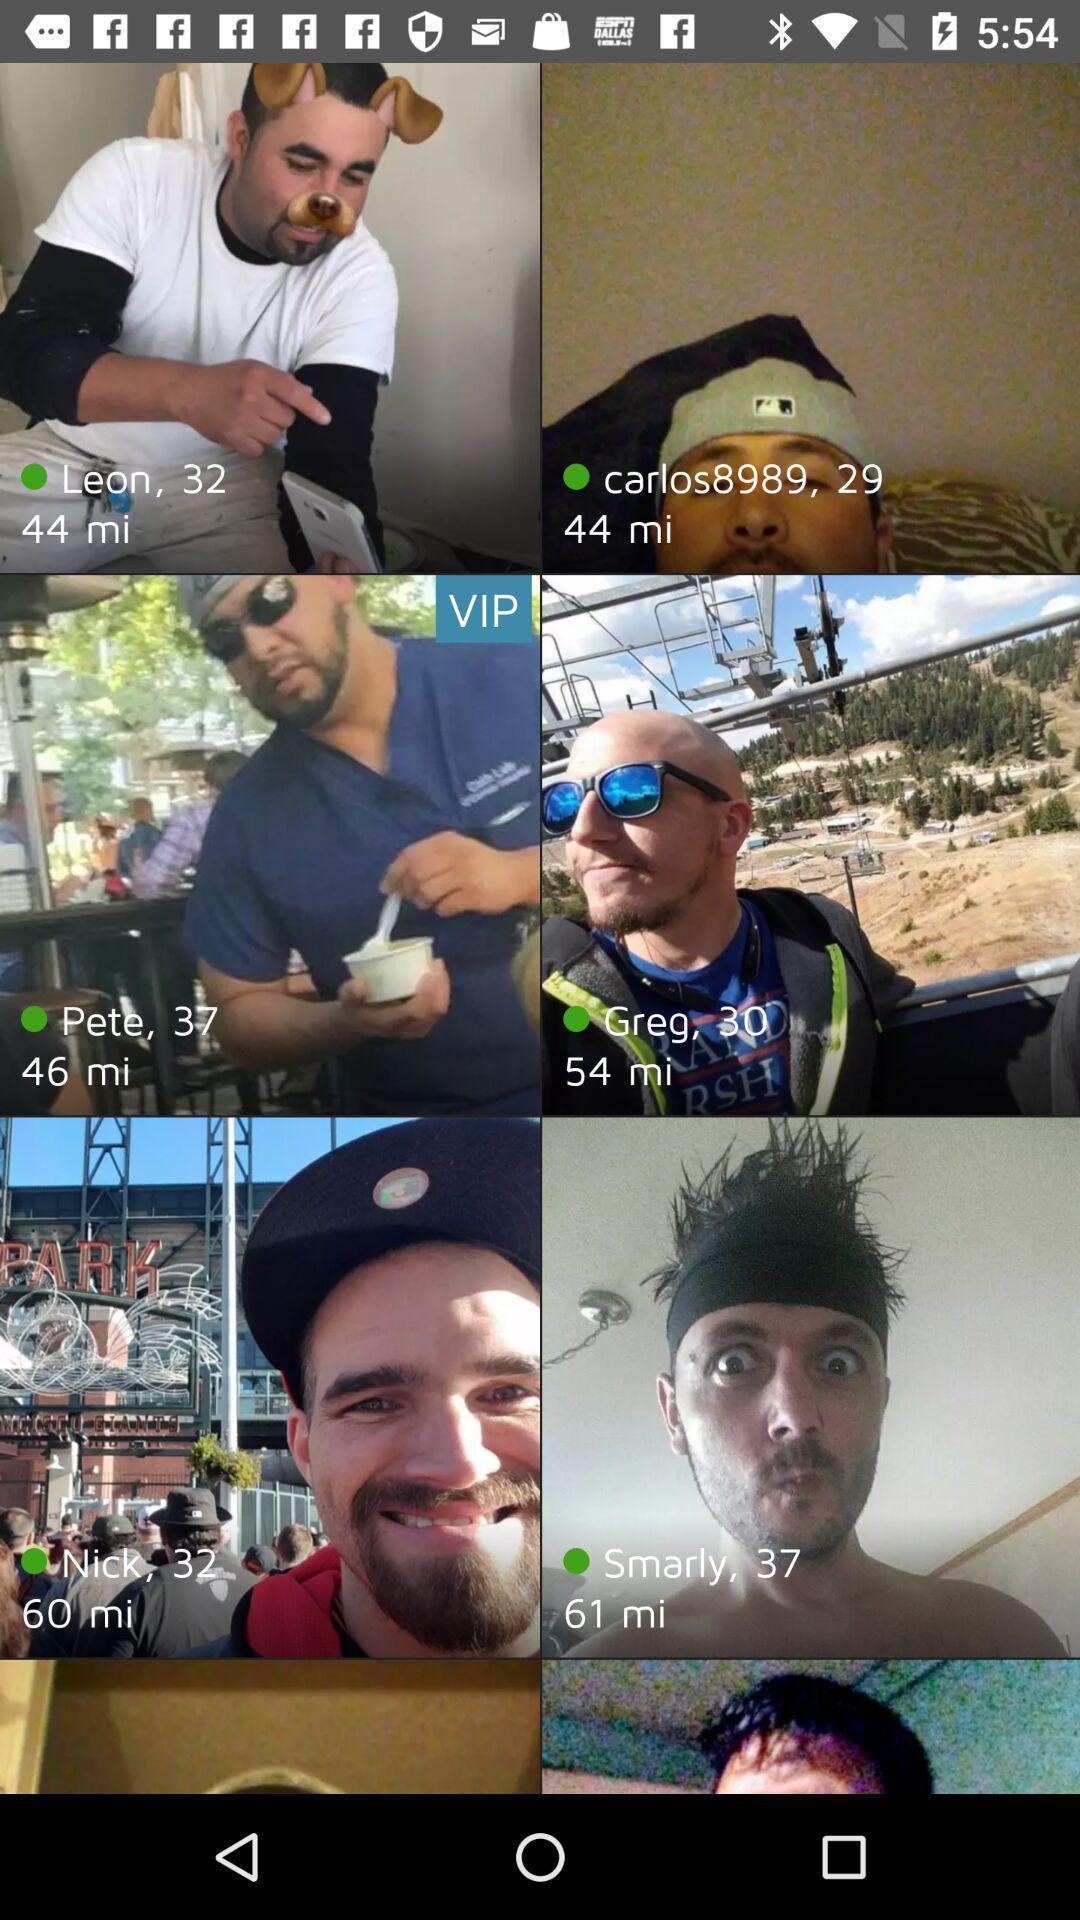Provide a detailed account of this screenshot. Screen showing various images. 